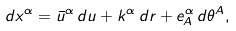Convert formula to latex. <formula><loc_0><loc_0><loc_500><loc_500>d x ^ { \alpha } = \bar { u } ^ { \alpha } \, d u + k ^ { \alpha } \, d r + e ^ { \alpha } _ { A } \, d \theta ^ { A } ,</formula> 